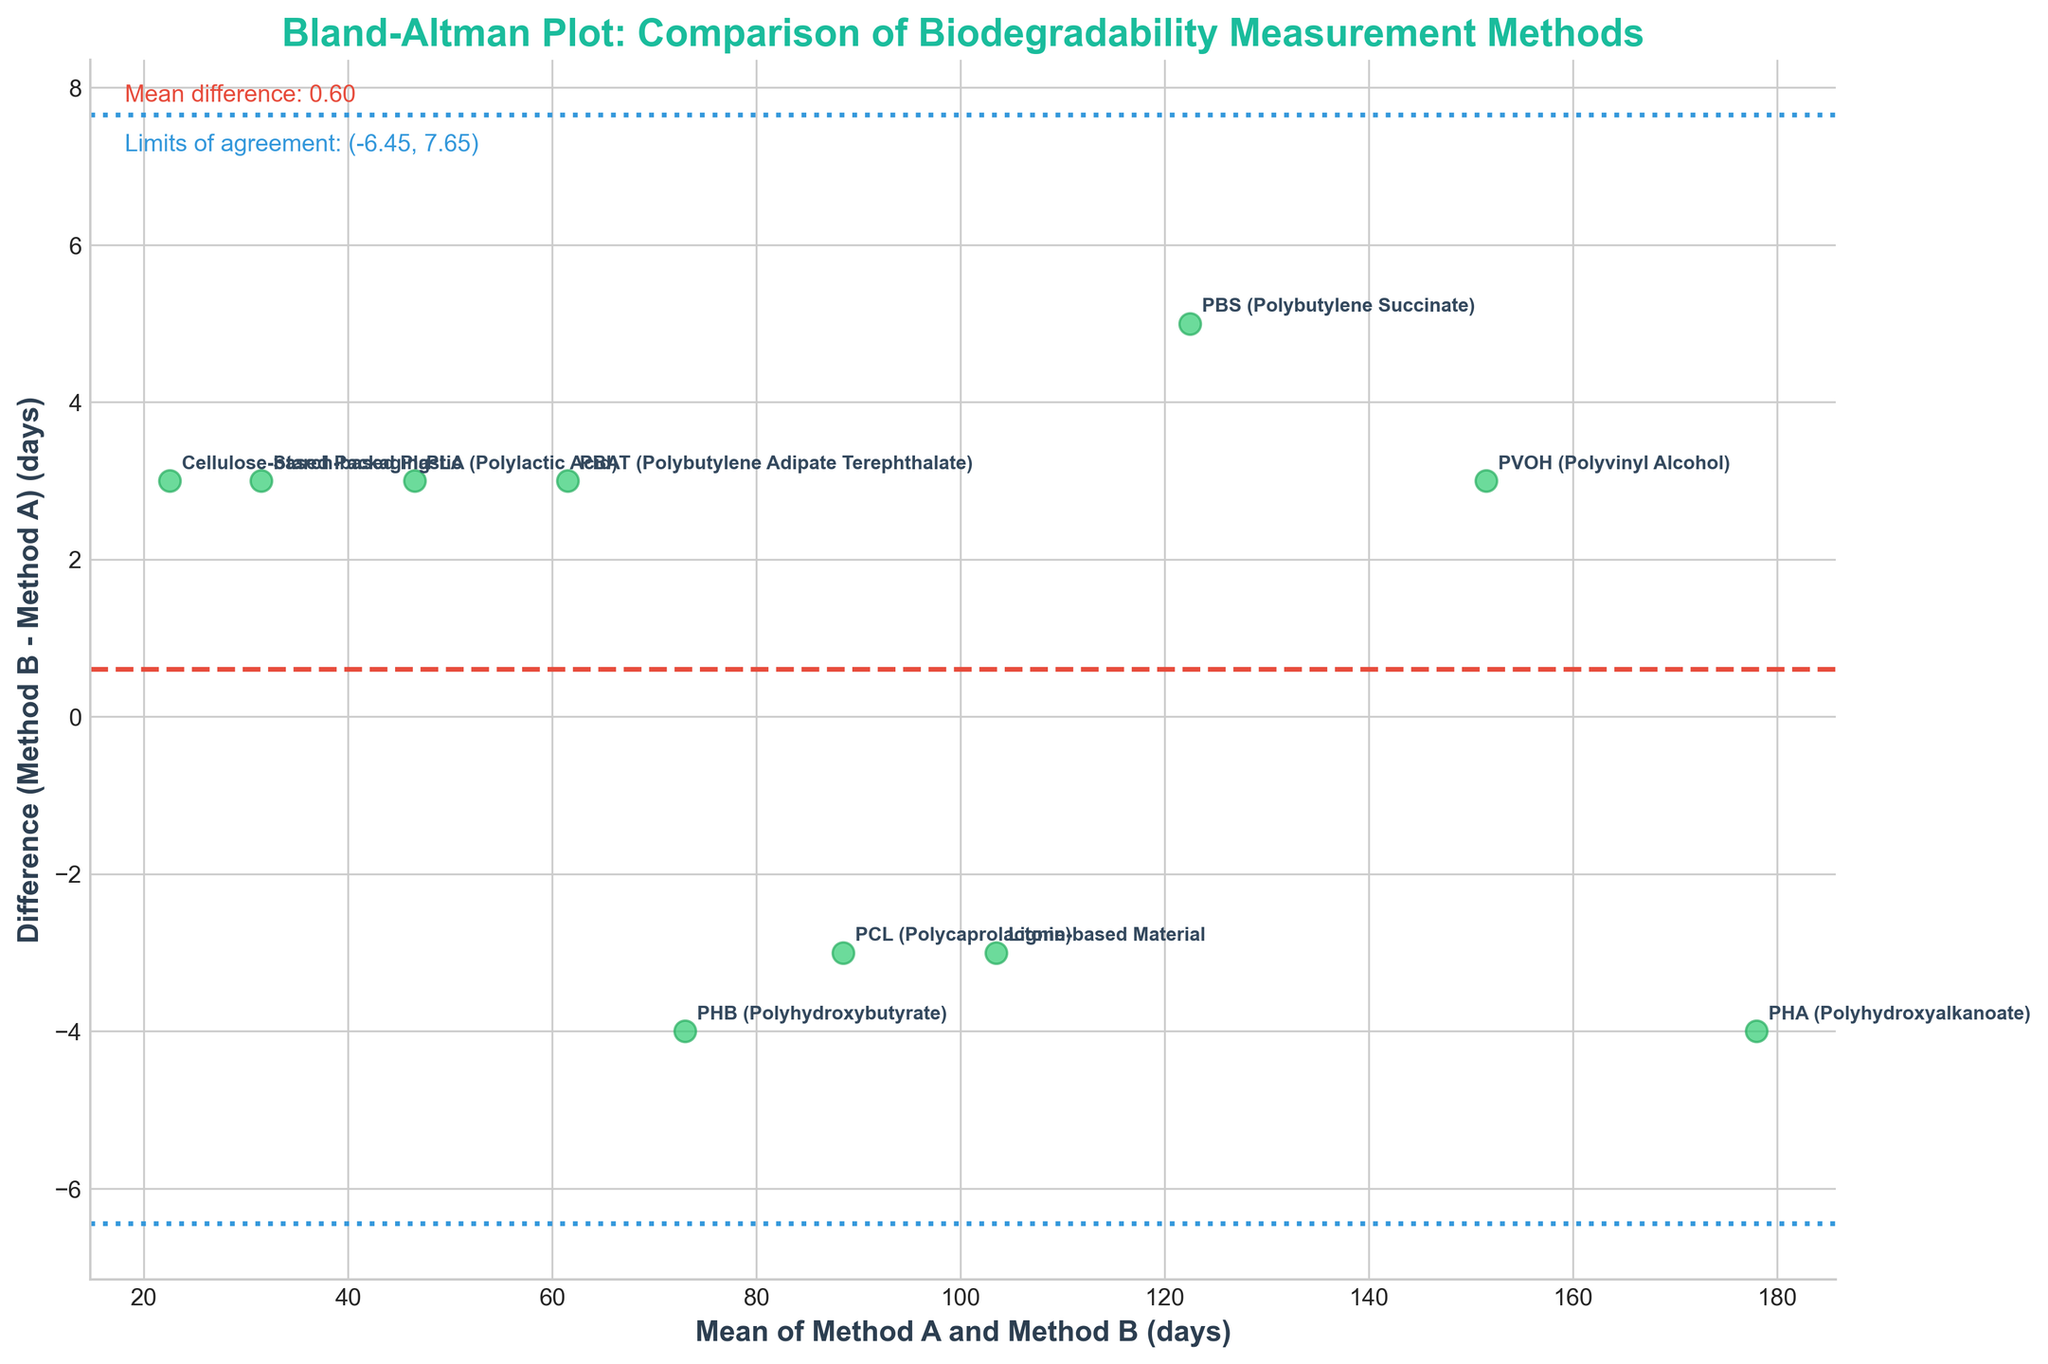What is the title of the plot? The title of the plot is shown at the top of the figure and usually summarizes the purpose of the plot. It reads "Bland-Altman Plot: Comparison of Biodegradability Measurement Methods".
Answer: Bland-Altman Plot: Comparison of Biodegradability Measurement Methods What do the x and y axes represent? The x-axis represents the "Mean of Method A and Method B (days)", while the y-axis represents the "Difference (Method B - Method A) (days)". This can be inferred from the axis labels in the plot.
Answer: x-axis: Mean of Method A and Method B (days), y-axis: Difference (Method B - Method A) (days) How many materials are evaluated in the plot? Each point in the scatter plot corresponds to a material evaluated, and from the data labels in the plot, it can be counted that there are 10 materials.
Answer: 10 What is the mean difference between Method B and Method A? The mean difference is indicated by the red dashed line, which is labeled near the top-left corner of the plot. The text annotation reads "Mean difference: 1.70".
Answer: 1.70 What are the limits of agreement in the plot? The limits of agreement are depicted by the two blue dotted lines and are labeled near the top-left corner of the plot. The text annotation reads "Limits of agreement: (-1.68, 5.08)".
Answer: (-1.68, 5.08) Which material has the largest positive difference between Method B and Method A? The material with the largest positive difference between Method B and Method A has the highest point on the y-axis. By identifying the highest labeled point, the material is "PBS (Polybutylene Succinate)".
Answer: PBS (Polybutylene Succinate) Which material has the largest negative difference between Method B and Method A? The material with the largest negative difference between Method B and Method A has the lowest point on the y-axis. By finding the lowest labeled point, the material is "PHB (Polyhydroxybutyrate)".
Answer: PHB (Polyhydroxybutyrate) Does any material lie outside the limits of agreement? To answer, check if any points lie outside the blue dotted lines representing the limits of agreement (-1.68, 5.08). From the plot, all points lie within these lines.
Answer: No Which material has the highest mean biodegradability measurement between Method A and Method B? The highest mean biodegradability measurement is represented by the rightmost point on the x-axis. The material corresponding to this point is "PHA (Polyhydroxyalkanoate)".
Answer: PHA (Polyhydroxyalkanoate) What do the blue dotted lines represent in the plot? The blue dotted lines represent the limits of agreement, which are the mean difference plus and minus 1.96 times the standard deviation of the differences. This is usually annotated and described on a Bland-Altman plot.
Answer: Limits of agreement 